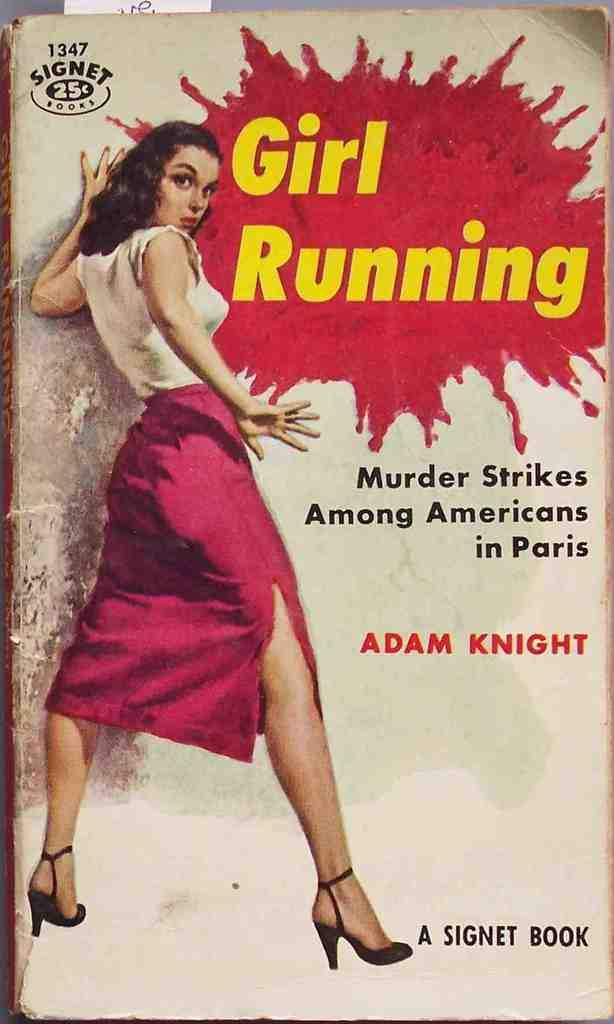<image>
Offer a succinct explanation of the picture presented. A book by Adam Knight sells for $0.25. 